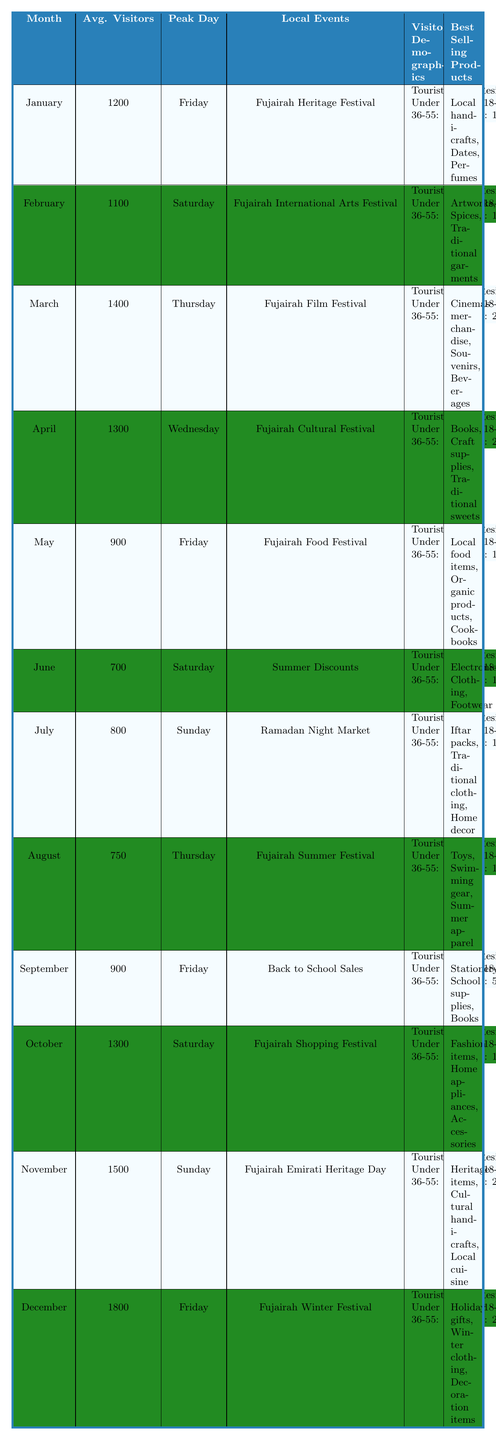What is the average number of visitors in December? According to the table, December shows an average of 1800 visitors.
Answer: 1800 Which month had the lowest average visitor count? By reviewing the data, June has the lowest average with 700 visitors.
Answer: June What is the peak day for the Fujairah Food Festival? The table indicates that the peak day for the Fujairah Food Festival is Friday.
Answer: Friday In which month do the most tourists visit, and how many are there? In December, the number of tourists reaches 900, which is the highest for any month.
Answer: December, 900 What is the total number of visitors from tourists in November? The table states that there are 800 tourists in November.
Answer: 800 How many total visitors are there in the month with the highest average? The table notes December has the highest average of 1800 visitors.
Answer: 1800 What age group has the highest number of visitors in January? For January, the age group 18-35 has the highest count of 500 visitors.
Answer: 18-35 (500) Is the average number of visitors in March greater than that in November? March has 1400 visitors, while November has 1500; thus, March's average is not greater.
Answer: No What is the best-selling product in April? According to the data, the best-selling products in April are books, craft supplies, and traditional sweets.
Answer: Books, craft supplies, traditional sweets How many more local events occur in November compared to June? The table shows that November has one local event while June has one; thus, there is no difference.
Answer: No difference Which month has a peak visitor count on a Wednesday? The table indicates April has the peak visitor count on a Wednesday.
Answer: April If we consider only residents, which month has the highest number visiting? November has 700 residents visiting, which is the highest documented in the table.
Answer: November, 700 Do tourists make up more than half of the visitors in October? October has 700 tourists out of 1300 total visitors, which means tourists make up about 54% of the total.
Answer: Yes Calculate the difference in average visitors between April and May. April averages 1300 visitors while May has 900, the difference is 1300 - 900 = 400.
Answer: 400 